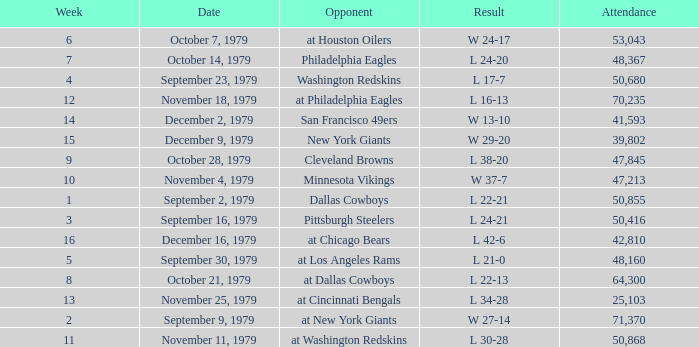What result in a week over 2 occurred with an attendance greater than 53,043 on November 18, 1979? L 16-13. 